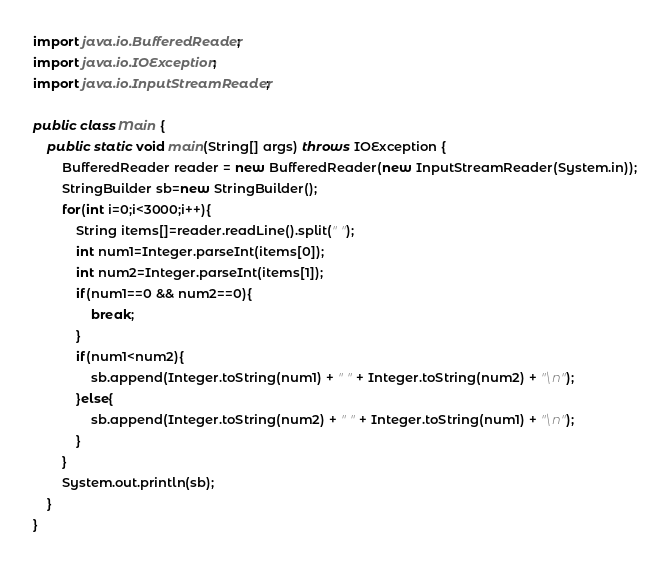<code> <loc_0><loc_0><loc_500><loc_500><_Java_>import java.io.BufferedReader;
import java.io.IOException;
import java.io.InputStreamReader;

public class Main {
	public static void main(String[] args) throws IOException {
        BufferedReader reader = new BufferedReader(new InputStreamReader(System.in));
        StringBuilder sb=new StringBuilder();
        for(int i=0;i<3000;i++){
        	String items[]=reader.readLine().split(" ");
        	int num1=Integer.parseInt(items[0]);
        	int num2=Integer.parseInt(items[1]);
            if(num1==0 && num2==0){
            	break;
            }
        	if(num1<num2){
            	sb.append(Integer.toString(num1) + " " + Integer.toString(num2) + "\n");
        	}else{
            	sb.append(Integer.toString(num2) + " " + Integer.toString(num1) + "\n");
        	}
        }
        System.out.println(sb);
	}
}</code> 